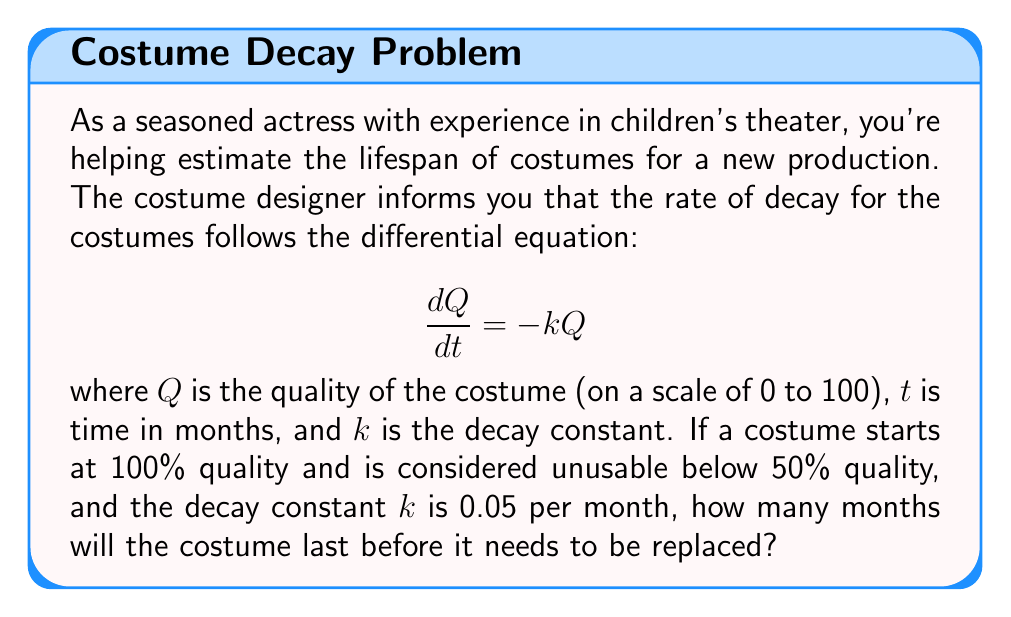Teach me how to tackle this problem. To solve this problem, we need to use the solution to the first-order linear differential equation given:

1) The general solution to $\frac{dQ}{dt} = -kQ$ is:

   $$Q(t) = Q_0e^{-kt}$$

   where $Q_0$ is the initial quality.

2) We're given that $Q_0 = 100$ (initial quality) and $k = 0.05$ per month.

3) We need to find $t$ when $Q(t) = 50$ (the point at which the costume becomes unusable).

4) Substituting these values into the equation:

   $$50 = 100e^{-0.05t}$$

5) Dividing both sides by 100:

   $$0.5 = e^{-0.05t}$$

6) Taking the natural logarithm of both sides:

   $$\ln(0.5) = -0.05t$$

7) Solving for $t$:

   $$t = \frac{\ln(0.5)}{-0.05} = \frac{-0.693147}{-0.05} \approx 13.86$$

Therefore, the costume will last approximately 13.86 months before it needs to be replaced.
Answer: The costume will last approximately 13.86 months before it needs to be replaced. 